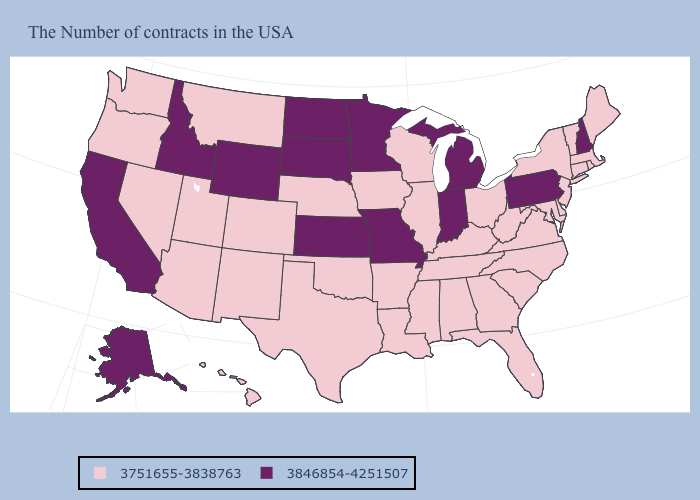What is the lowest value in the MidWest?
Quick response, please. 3751655-3838763. What is the highest value in states that border South Carolina?
Concise answer only. 3751655-3838763. Does the first symbol in the legend represent the smallest category?
Quick response, please. Yes. Does the map have missing data?
Answer briefly. No. Does Rhode Island have the lowest value in the USA?
Concise answer only. Yes. What is the lowest value in states that border Illinois?
Short answer required. 3751655-3838763. What is the value of Pennsylvania?
Be succinct. 3846854-4251507. Is the legend a continuous bar?
Be succinct. No. What is the highest value in the Northeast ?
Concise answer only. 3846854-4251507. Is the legend a continuous bar?
Be succinct. No. Among the states that border Delaware , does Pennsylvania have the lowest value?
Answer briefly. No. Which states have the highest value in the USA?
Be succinct. New Hampshire, Pennsylvania, Michigan, Indiana, Missouri, Minnesota, Kansas, South Dakota, North Dakota, Wyoming, Idaho, California, Alaska. Does Texas have a lower value than Maine?
Short answer required. No. What is the value of Arizona?
Give a very brief answer. 3751655-3838763. Which states have the lowest value in the South?
Quick response, please. Delaware, Maryland, Virginia, North Carolina, South Carolina, West Virginia, Florida, Georgia, Kentucky, Alabama, Tennessee, Mississippi, Louisiana, Arkansas, Oklahoma, Texas. 